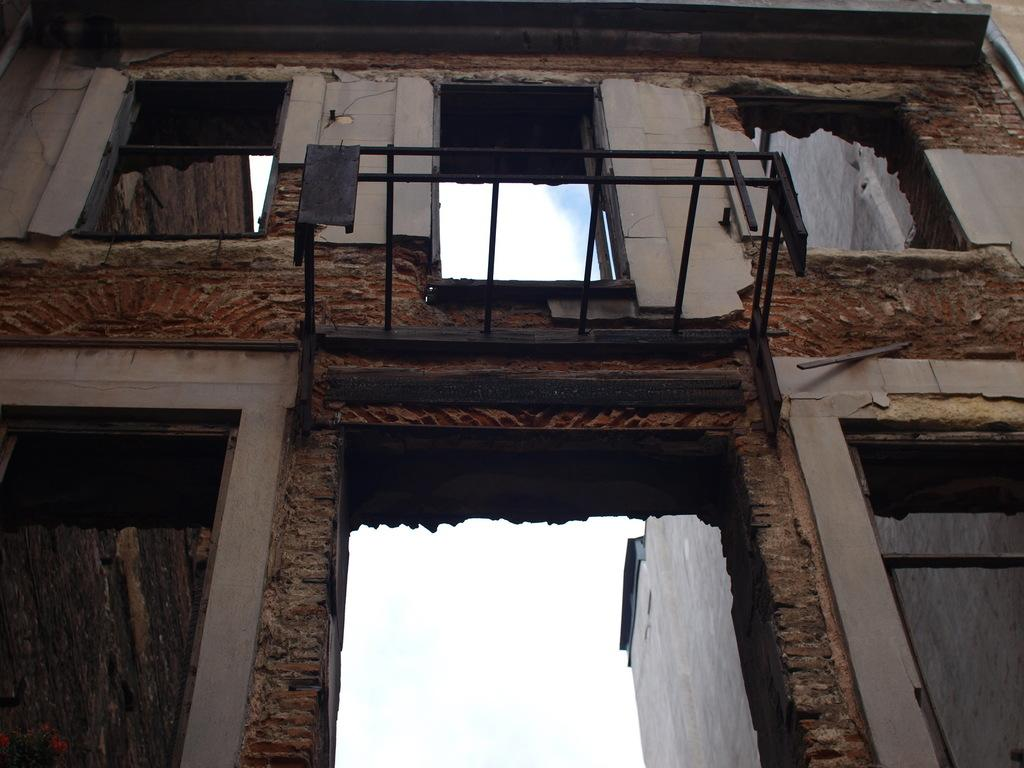From what perspective is the image taken? The image is taken from a lower angle. What type of structure can be seen in the image? There is a building in the image. What other architectural element is present in the image? There is a wall in the image. What can be seen in the background of the image? The sky is visible in the background of the image. How much money is being exchanged between the hands in the image? There are no hands or money present in the image. What type of farm animals can be seen grazing in the image? There are no farm animals or any indication of a farm in the image. 